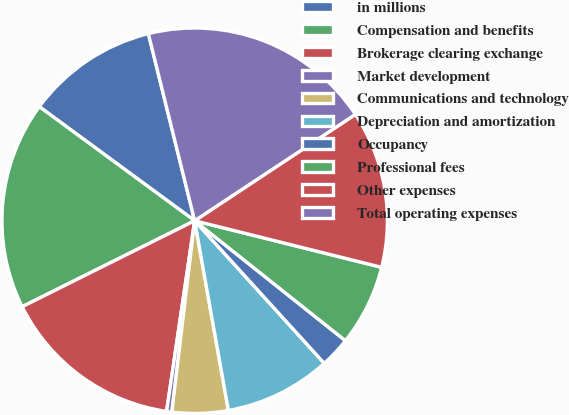<chart> <loc_0><loc_0><loc_500><loc_500><pie_chart><fcel>in millions<fcel>Compensation and benefits<fcel>Brokerage clearing exchange<fcel>Market development<fcel>Communications and technology<fcel>Depreciation and amortization<fcel>Occupancy<fcel>Professional fees<fcel>Other expenses<fcel>Total operating expenses<nl><fcel>11.06%<fcel>17.44%<fcel>15.31%<fcel>0.44%<fcel>4.69%<fcel>8.94%<fcel>2.56%<fcel>6.81%<fcel>13.19%<fcel>19.56%<nl></chart> 